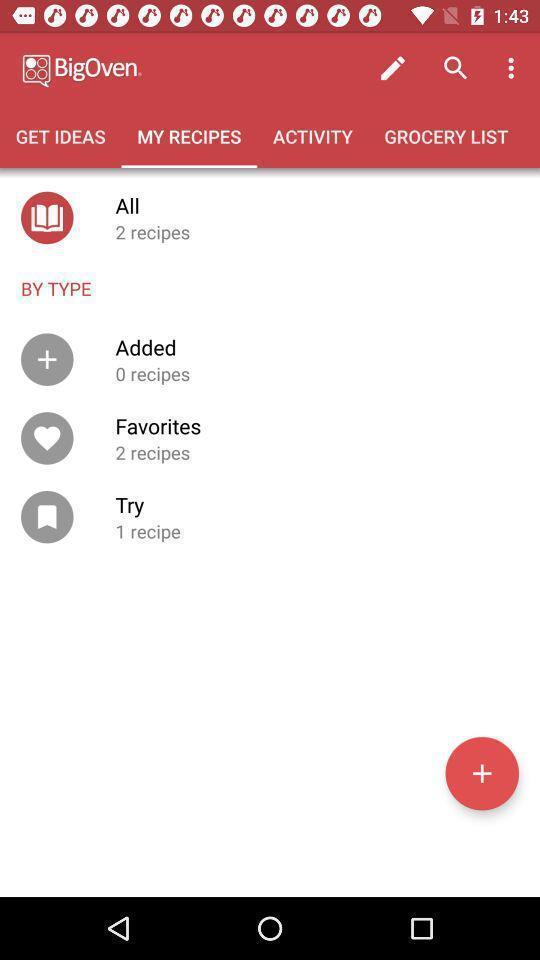Tell me what you see in this picture. Window displaying a cooking app. 